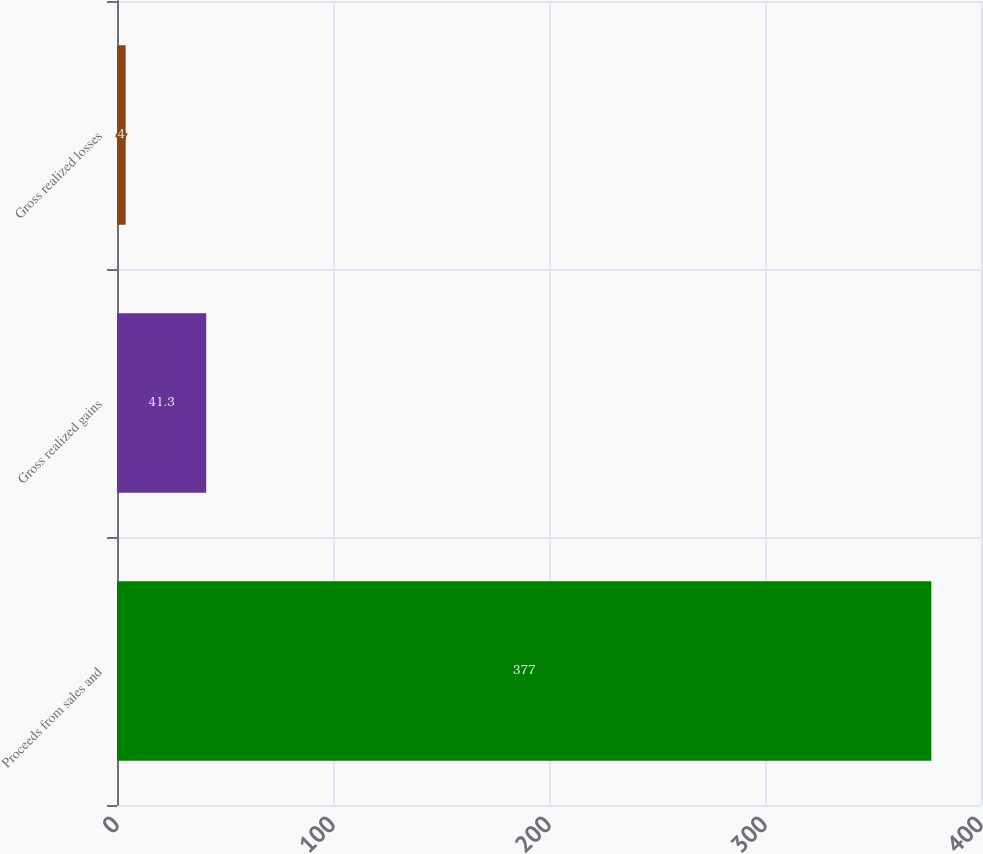<chart> <loc_0><loc_0><loc_500><loc_500><bar_chart><fcel>Proceeds from sales and<fcel>Gross realized gains<fcel>Gross realized losses<nl><fcel>377<fcel>41.3<fcel>4<nl></chart> 